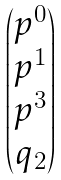Convert formula to latex. <formula><loc_0><loc_0><loc_500><loc_500>\begin{pmatrix} p ^ { 0 } \\ p ^ { 1 } \\ p ^ { 3 } \\ q _ { 2 } \end{pmatrix}</formula> 